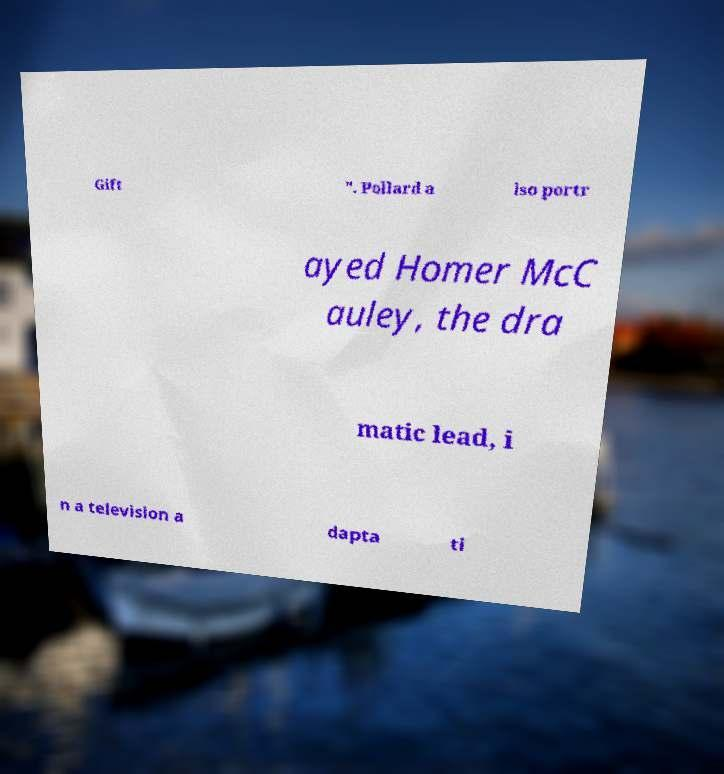Please read and relay the text visible in this image. What does it say? Gift ". Pollard a lso portr ayed Homer McC auley, the dra matic lead, i n a television a dapta ti 